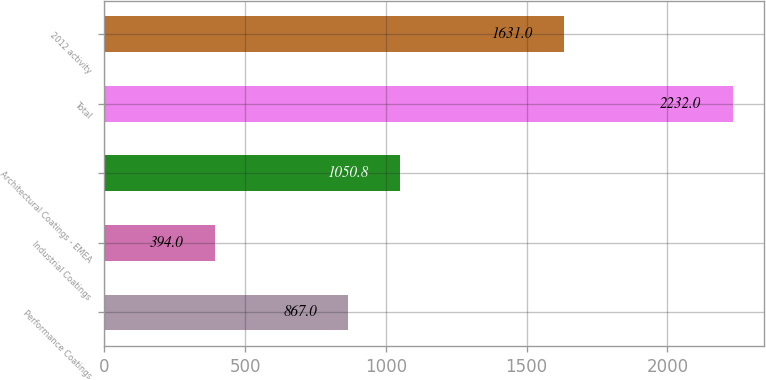<chart> <loc_0><loc_0><loc_500><loc_500><bar_chart><fcel>Performance Coatings<fcel>Industrial Coatings<fcel>Architectural Coatings - EMEA<fcel>Total<fcel>2012 activity<nl><fcel>867<fcel>394<fcel>1050.8<fcel>2232<fcel>1631<nl></chart> 